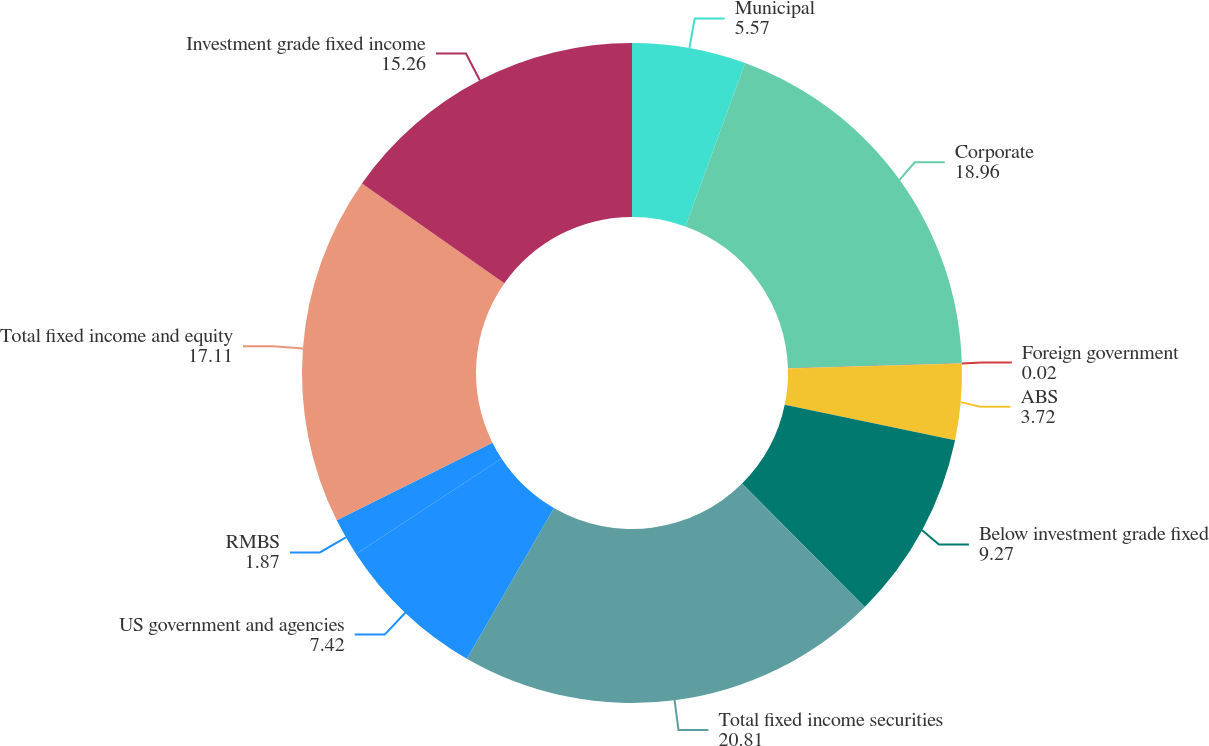<chart> <loc_0><loc_0><loc_500><loc_500><pie_chart><fcel>Municipal<fcel>Corporate<fcel>Foreign government<fcel>ABS<fcel>Below investment grade fixed<fcel>Total fixed income securities<fcel>US government and agencies<fcel>RMBS<fcel>Total fixed income and equity<fcel>Investment grade fixed income<nl><fcel>5.57%<fcel>18.96%<fcel>0.02%<fcel>3.72%<fcel>9.27%<fcel>20.81%<fcel>7.42%<fcel>1.87%<fcel>17.11%<fcel>15.26%<nl></chart> 